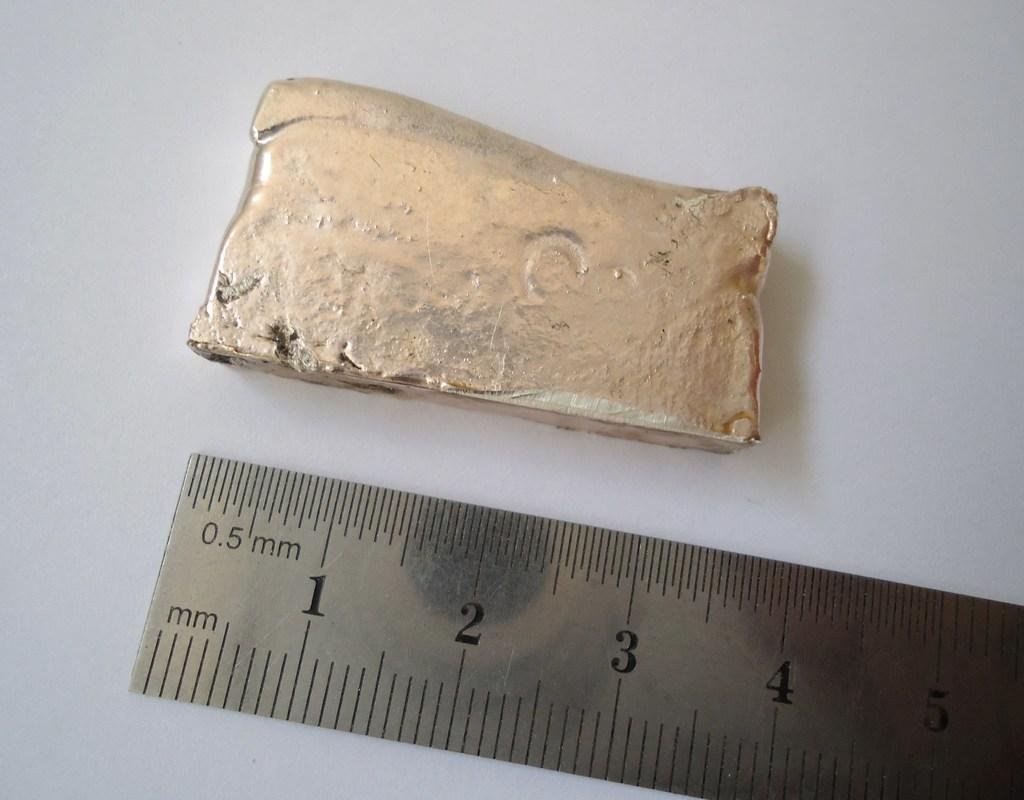Provide a one-sentence caption for the provided image. A piece of artifact with a scale with metric measurement. 